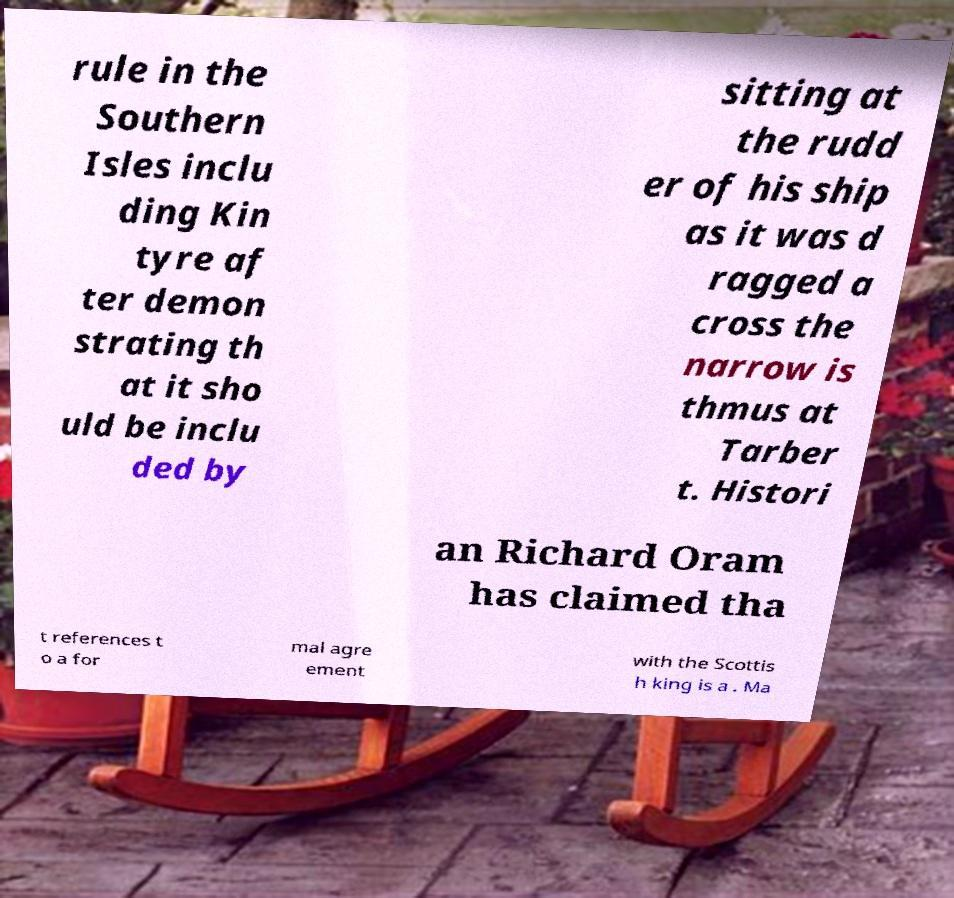I need the written content from this picture converted into text. Can you do that? rule in the Southern Isles inclu ding Kin tyre af ter demon strating th at it sho uld be inclu ded by sitting at the rudd er of his ship as it was d ragged a cross the narrow is thmus at Tarber t. Histori an Richard Oram has claimed tha t references t o a for mal agre ement with the Scottis h king is a . Ma 